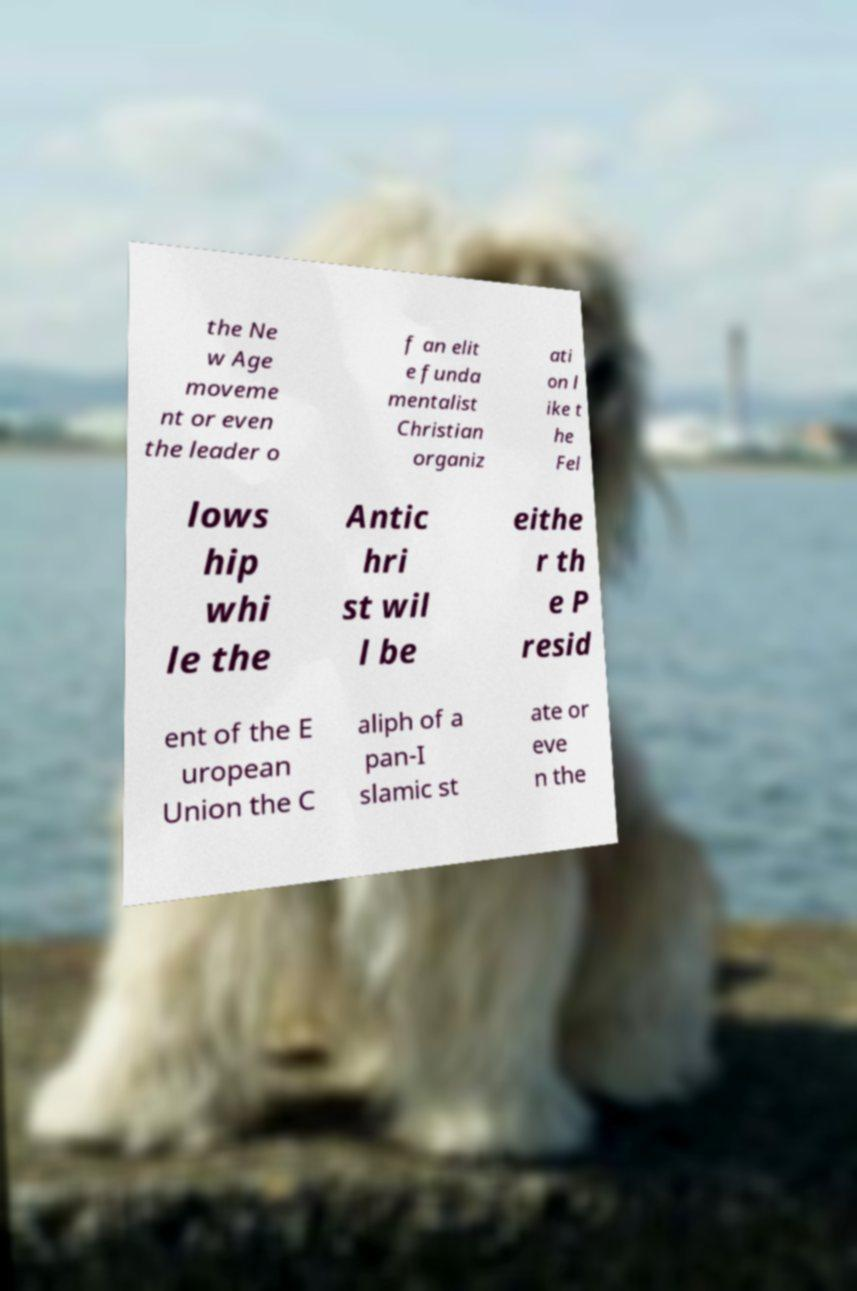Please read and relay the text visible in this image. What does it say? the Ne w Age moveme nt or even the leader o f an elit e funda mentalist Christian organiz ati on l ike t he Fel lows hip whi le the Antic hri st wil l be eithe r th e P resid ent of the E uropean Union the C aliph of a pan-I slamic st ate or eve n the 